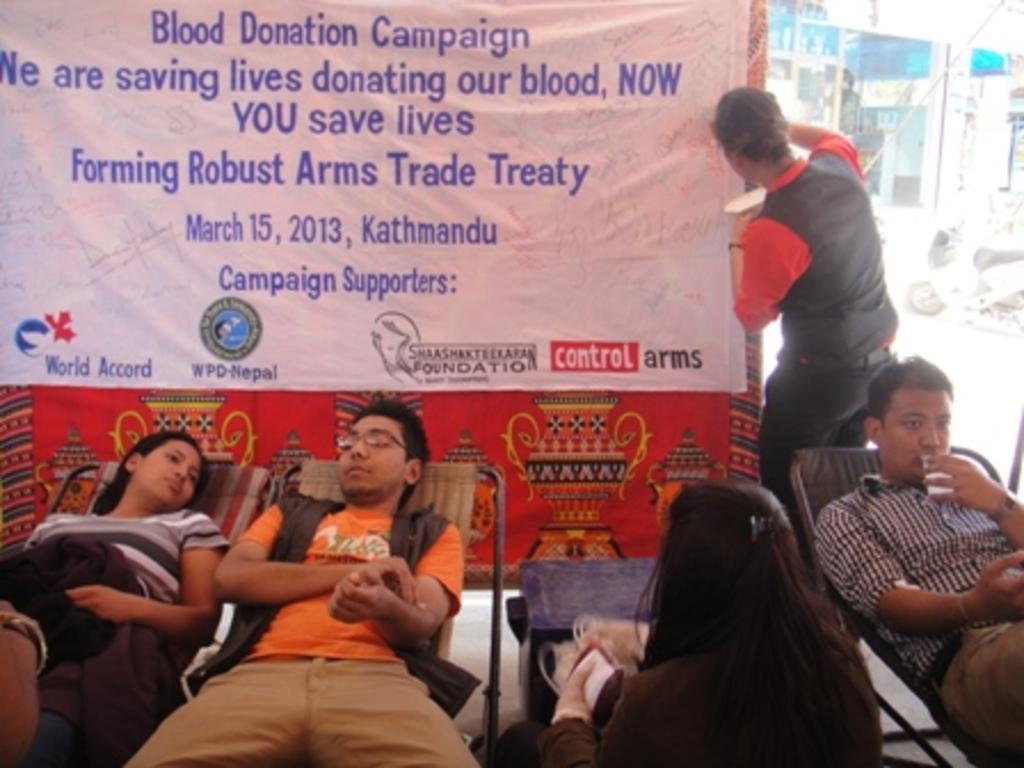Please provide a concise description of this image. In the image we can see three persons are lying one is sitting and one is standing. This is a poster. There are even buildings and a vehicle. 